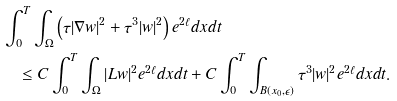<formula> <loc_0><loc_0><loc_500><loc_500>& \int _ { 0 } ^ { T } \int _ { \Omega } \left ( \tau | \nabla w | ^ { 2 } + \tau ^ { 3 } | w | ^ { 2 } \right ) e ^ { 2 \ell } d x d t \\ & \quad \leq C \int _ { 0 } ^ { T } \int _ { \Omega } | L w | ^ { 2 } e ^ { 2 \ell } d x d t + C \int _ { 0 } ^ { T } \int _ { B ( x _ { 0 } , \epsilon ) } \tau ^ { 3 } | w | ^ { 2 } e ^ { 2 \ell } d x d t .</formula> 